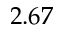Convert formula to latex. <formula><loc_0><loc_0><loc_500><loc_500>2 . 6 7</formula> 